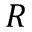<formula> <loc_0><loc_0><loc_500><loc_500>R</formula> 